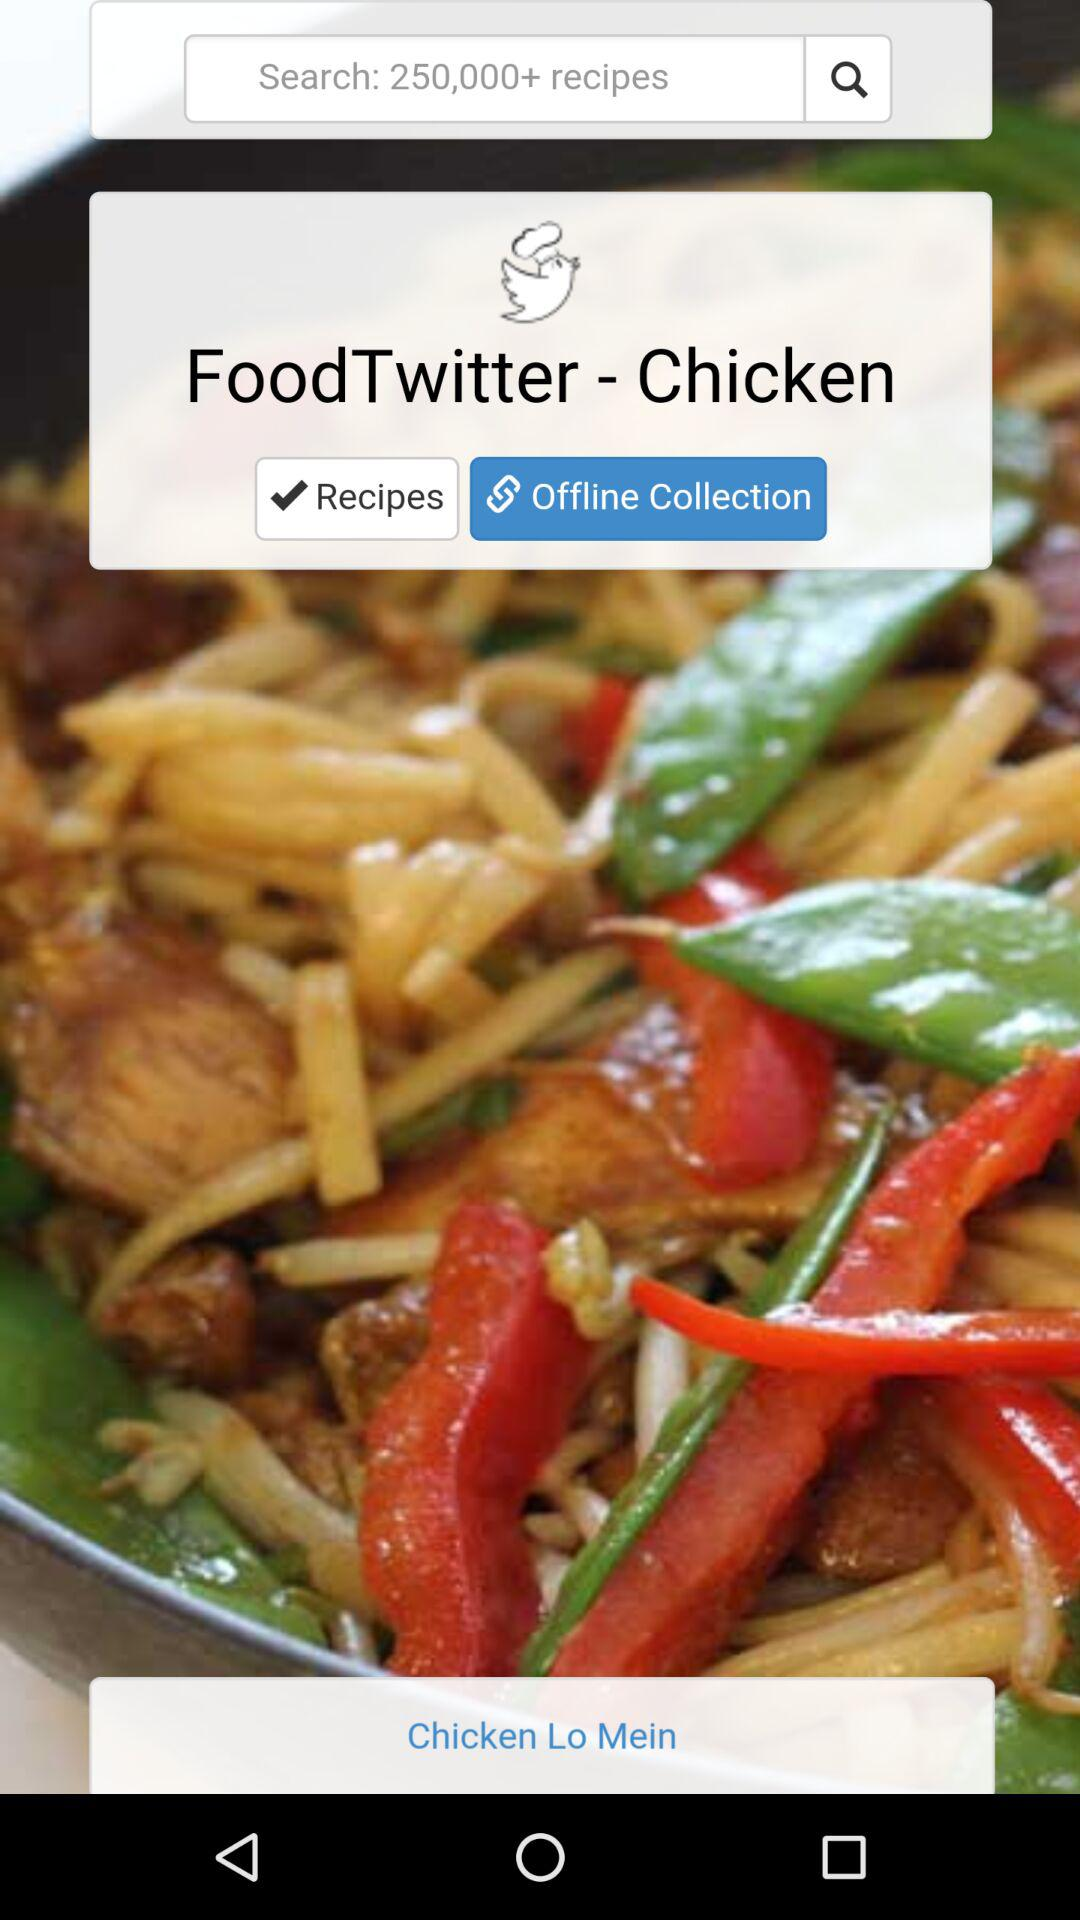How many recipes are given in the search option? In the search option, 250,000+ recipes are given. 